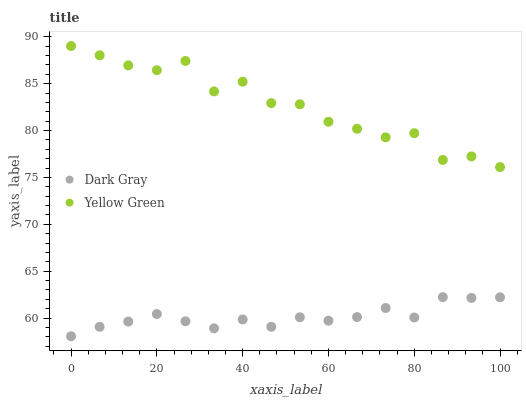Does Dark Gray have the minimum area under the curve?
Answer yes or no. Yes. Does Yellow Green have the maximum area under the curve?
Answer yes or no. Yes. Does Yellow Green have the minimum area under the curve?
Answer yes or no. No. Is Dark Gray the smoothest?
Answer yes or no. Yes. Is Yellow Green the roughest?
Answer yes or no. Yes. Is Yellow Green the smoothest?
Answer yes or no. No. Does Dark Gray have the lowest value?
Answer yes or no. Yes. Does Yellow Green have the lowest value?
Answer yes or no. No. Does Yellow Green have the highest value?
Answer yes or no. Yes. Is Dark Gray less than Yellow Green?
Answer yes or no. Yes. Is Yellow Green greater than Dark Gray?
Answer yes or no. Yes. Does Dark Gray intersect Yellow Green?
Answer yes or no. No. 